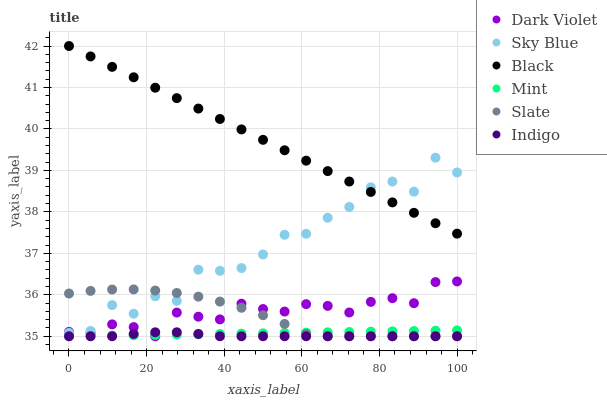Does Indigo have the minimum area under the curve?
Answer yes or no. Yes. Does Black have the maximum area under the curve?
Answer yes or no. Yes. Does Slate have the minimum area under the curve?
Answer yes or no. No. Does Slate have the maximum area under the curve?
Answer yes or no. No. Is Mint the smoothest?
Answer yes or no. Yes. Is Sky Blue the roughest?
Answer yes or no. Yes. Is Slate the smoothest?
Answer yes or no. No. Is Slate the roughest?
Answer yes or no. No. Does Indigo have the lowest value?
Answer yes or no. Yes. Does Black have the lowest value?
Answer yes or no. No. Does Black have the highest value?
Answer yes or no. Yes. Does Slate have the highest value?
Answer yes or no. No. Is Mint less than Sky Blue?
Answer yes or no. Yes. Is Black greater than Indigo?
Answer yes or no. Yes. Does Mint intersect Slate?
Answer yes or no. Yes. Is Mint less than Slate?
Answer yes or no. No. Is Mint greater than Slate?
Answer yes or no. No. Does Mint intersect Sky Blue?
Answer yes or no. No. 